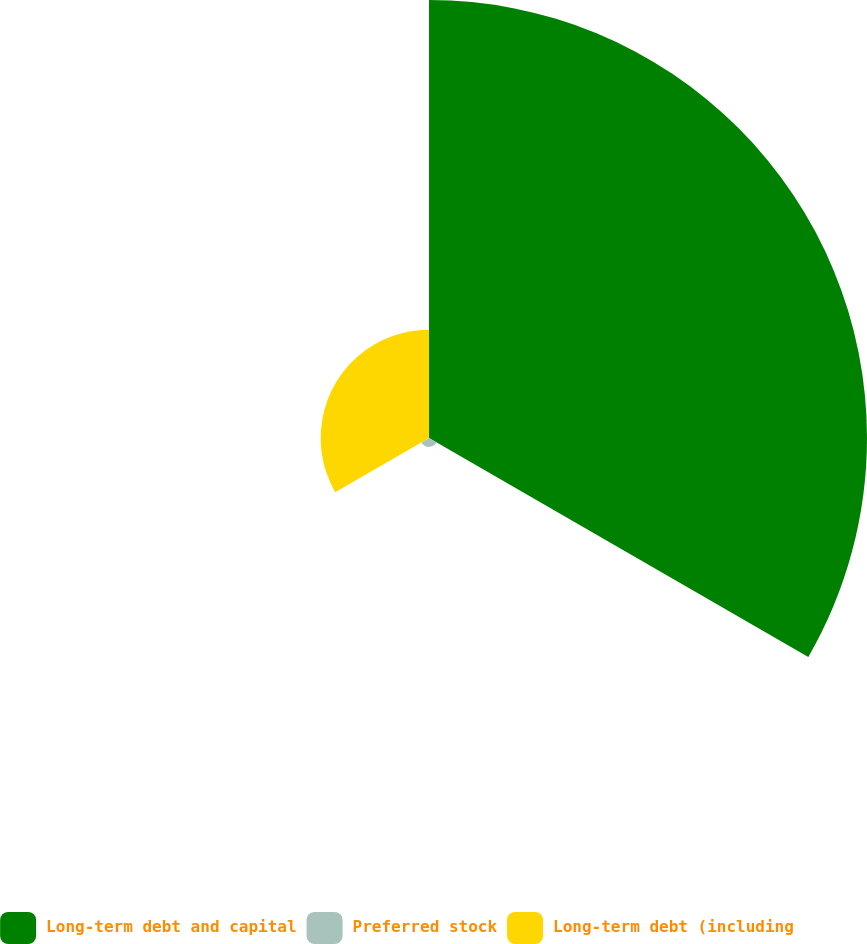Convert chart. <chart><loc_0><loc_0><loc_500><loc_500><pie_chart><fcel>Long-term debt and capital<fcel>Preferred stock<fcel>Long-term debt (including<nl><fcel>78.88%<fcel>1.6%<fcel>19.51%<nl></chart> 